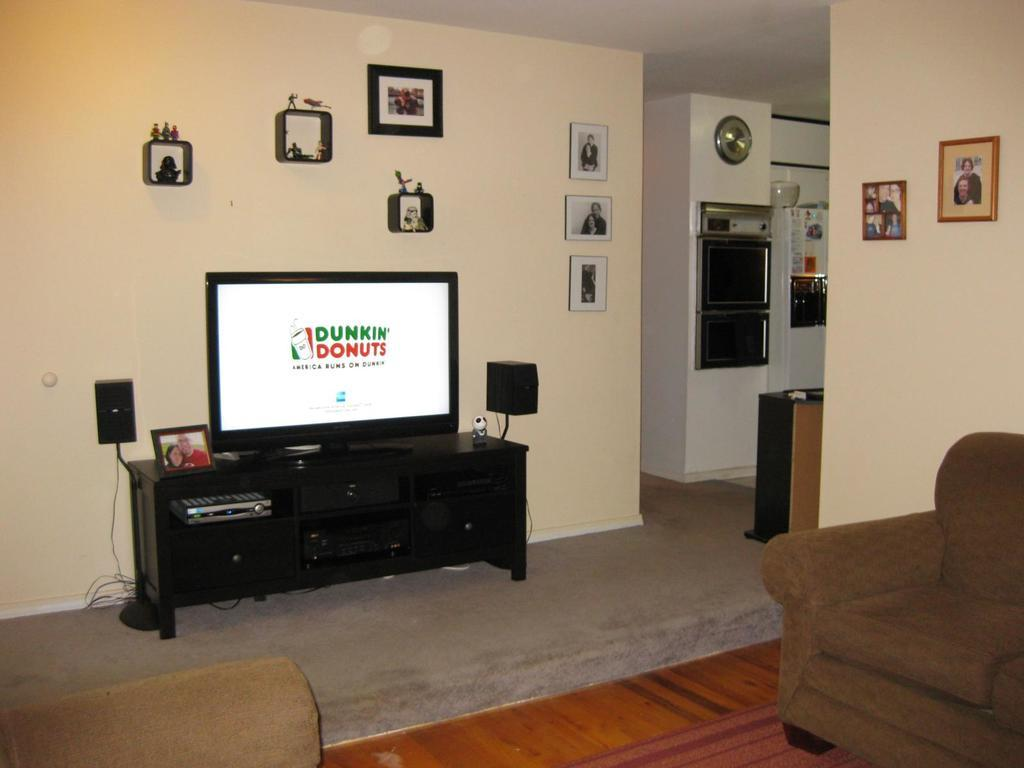Where is the table located in the room? The table is in the room against a wall. What is on top of the table? A TV and a frame are present on the table. What can be seen on the wall? There are frames on the wall and a clock. How many chairs are in the room? There are 2 chairs in the room. Can you tell me how many jars are on the table? There is no jar present on the table in the image. Do you believe the clock on the wall is accurate? The accuracy of the clock cannot be determined from the image alone. 